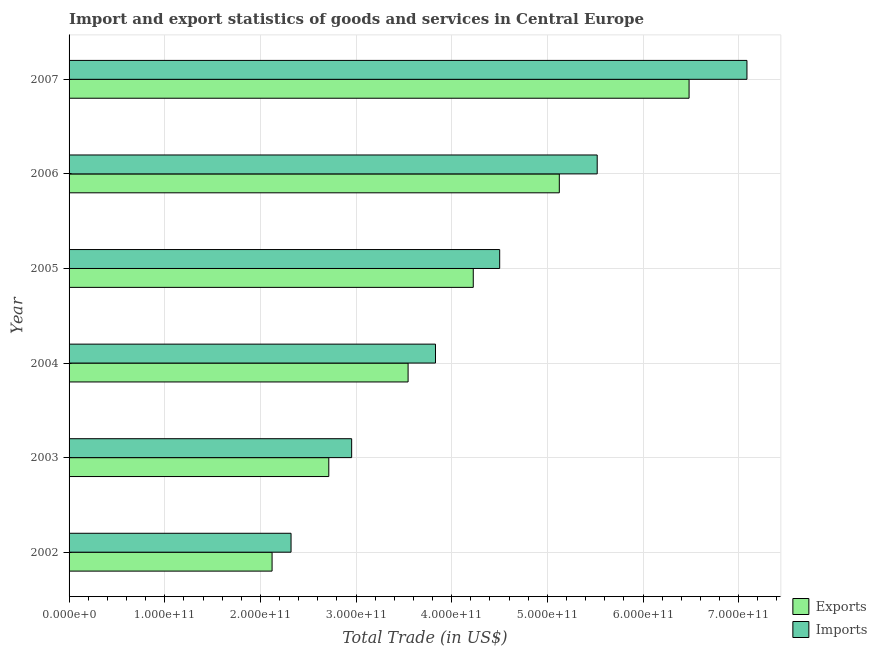How many different coloured bars are there?
Ensure brevity in your answer.  2. How many groups of bars are there?
Make the answer very short. 6. Are the number of bars per tick equal to the number of legend labels?
Your answer should be very brief. Yes. What is the export of goods and services in 2003?
Your answer should be very brief. 2.72e+11. Across all years, what is the maximum imports of goods and services?
Ensure brevity in your answer.  7.09e+11. Across all years, what is the minimum imports of goods and services?
Give a very brief answer. 2.32e+11. In which year was the imports of goods and services maximum?
Your response must be concise. 2007. In which year was the imports of goods and services minimum?
Offer a very short reply. 2002. What is the total imports of goods and services in the graph?
Your response must be concise. 2.62e+12. What is the difference between the imports of goods and services in 2003 and that in 2004?
Provide a succinct answer. -8.76e+1. What is the difference between the imports of goods and services in 2002 and the export of goods and services in 2007?
Offer a terse response. -4.16e+11. What is the average imports of goods and services per year?
Keep it short and to the point. 4.37e+11. In the year 2007, what is the difference between the export of goods and services and imports of goods and services?
Ensure brevity in your answer.  -6.05e+1. What is the ratio of the imports of goods and services in 2003 to that in 2006?
Give a very brief answer. 0.54. Is the imports of goods and services in 2003 less than that in 2007?
Your answer should be compact. Yes. What is the difference between the highest and the second highest export of goods and services?
Provide a succinct answer. 1.36e+11. What is the difference between the highest and the lowest export of goods and services?
Offer a very short reply. 4.36e+11. Is the sum of the imports of goods and services in 2002 and 2006 greater than the maximum export of goods and services across all years?
Your response must be concise. Yes. What does the 2nd bar from the top in 2004 represents?
Your response must be concise. Exports. What does the 1st bar from the bottom in 2003 represents?
Give a very brief answer. Exports. How many bars are there?
Make the answer very short. 12. Are all the bars in the graph horizontal?
Your answer should be compact. Yes. What is the difference between two consecutive major ticks on the X-axis?
Offer a terse response. 1.00e+11. Are the values on the major ticks of X-axis written in scientific E-notation?
Give a very brief answer. Yes. Where does the legend appear in the graph?
Keep it short and to the point. Bottom right. How many legend labels are there?
Ensure brevity in your answer.  2. What is the title of the graph?
Your answer should be very brief. Import and export statistics of goods and services in Central Europe. What is the label or title of the X-axis?
Make the answer very short. Total Trade (in US$). What is the label or title of the Y-axis?
Make the answer very short. Year. What is the Total Trade (in US$) of Exports in 2002?
Offer a terse response. 2.12e+11. What is the Total Trade (in US$) of Imports in 2002?
Provide a succinct answer. 2.32e+11. What is the Total Trade (in US$) of Exports in 2003?
Make the answer very short. 2.72e+11. What is the Total Trade (in US$) of Imports in 2003?
Ensure brevity in your answer.  2.95e+11. What is the Total Trade (in US$) in Exports in 2004?
Ensure brevity in your answer.  3.54e+11. What is the Total Trade (in US$) of Imports in 2004?
Give a very brief answer. 3.83e+11. What is the Total Trade (in US$) of Exports in 2005?
Give a very brief answer. 4.23e+11. What is the Total Trade (in US$) in Imports in 2005?
Provide a succinct answer. 4.50e+11. What is the Total Trade (in US$) in Exports in 2006?
Provide a short and direct response. 5.12e+11. What is the Total Trade (in US$) in Imports in 2006?
Give a very brief answer. 5.52e+11. What is the Total Trade (in US$) of Exports in 2007?
Offer a terse response. 6.48e+11. What is the Total Trade (in US$) of Imports in 2007?
Provide a succinct answer. 7.09e+11. Across all years, what is the maximum Total Trade (in US$) in Exports?
Make the answer very short. 6.48e+11. Across all years, what is the maximum Total Trade (in US$) in Imports?
Your response must be concise. 7.09e+11. Across all years, what is the minimum Total Trade (in US$) in Exports?
Make the answer very short. 2.12e+11. Across all years, what is the minimum Total Trade (in US$) of Imports?
Give a very brief answer. 2.32e+11. What is the total Total Trade (in US$) in Exports in the graph?
Provide a short and direct response. 2.42e+12. What is the total Total Trade (in US$) of Imports in the graph?
Ensure brevity in your answer.  2.62e+12. What is the difference between the Total Trade (in US$) in Exports in 2002 and that in 2003?
Make the answer very short. -5.93e+1. What is the difference between the Total Trade (in US$) of Imports in 2002 and that in 2003?
Your response must be concise. -6.34e+1. What is the difference between the Total Trade (in US$) in Exports in 2002 and that in 2004?
Ensure brevity in your answer.  -1.42e+11. What is the difference between the Total Trade (in US$) of Imports in 2002 and that in 2004?
Keep it short and to the point. -1.51e+11. What is the difference between the Total Trade (in US$) of Exports in 2002 and that in 2005?
Give a very brief answer. -2.10e+11. What is the difference between the Total Trade (in US$) of Imports in 2002 and that in 2005?
Your answer should be very brief. -2.18e+11. What is the difference between the Total Trade (in US$) in Exports in 2002 and that in 2006?
Your response must be concise. -3.00e+11. What is the difference between the Total Trade (in US$) in Imports in 2002 and that in 2006?
Your answer should be compact. -3.20e+11. What is the difference between the Total Trade (in US$) of Exports in 2002 and that in 2007?
Provide a short and direct response. -4.36e+11. What is the difference between the Total Trade (in US$) of Imports in 2002 and that in 2007?
Your answer should be compact. -4.77e+11. What is the difference between the Total Trade (in US$) of Exports in 2003 and that in 2004?
Your response must be concise. -8.29e+1. What is the difference between the Total Trade (in US$) in Imports in 2003 and that in 2004?
Offer a terse response. -8.76e+1. What is the difference between the Total Trade (in US$) of Exports in 2003 and that in 2005?
Your answer should be compact. -1.51e+11. What is the difference between the Total Trade (in US$) of Imports in 2003 and that in 2005?
Keep it short and to the point. -1.55e+11. What is the difference between the Total Trade (in US$) of Exports in 2003 and that in 2006?
Offer a very short reply. -2.41e+11. What is the difference between the Total Trade (in US$) of Imports in 2003 and that in 2006?
Your response must be concise. -2.57e+11. What is the difference between the Total Trade (in US$) in Exports in 2003 and that in 2007?
Provide a succinct answer. -3.77e+11. What is the difference between the Total Trade (in US$) of Imports in 2003 and that in 2007?
Offer a terse response. -4.13e+11. What is the difference between the Total Trade (in US$) in Exports in 2004 and that in 2005?
Provide a succinct answer. -6.81e+1. What is the difference between the Total Trade (in US$) of Imports in 2004 and that in 2005?
Give a very brief answer. -6.71e+1. What is the difference between the Total Trade (in US$) in Exports in 2004 and that in 2006?
Your response must be concise. -1.58e+11. What is the difference between the Total Trade (in US$) of Imports in 2004 and that in 2006?
Offer a terse response. -1.69e+11. What is the difference between the Total Trade (in US$) in Exports in 2004 and that in 2007?
Offer a very short reply. -2.94e+11. What is the difference between the Total Trade (in US$) of Imports in 2004 and that in 2007?
Your answer should be very brief. -3.26e+11. What is the difference between the Total Trade (in US$) in Exports in 2005 and that in 2006?
Provide a short and direct response. -8.99e+1. What is the difference between the Total Trade (in US$) in Imports in 2005 and that in 2006?
Provide a short and direct response. -1.02e+11. What is the difference between the Total Trade (in US$) of Exports in 2005 and that in 2007?
Offer a very short reply. -2.26e+11. What is the difference between the Total Trade (in US$) of Imports in 2005 and that in 2007?
Keep it short and to the point. -2.58e+11. What is the difference between the Total Trade (in US$) of Exports in 2006 and that in 2007?
Provide a succinct answer. -1.36e+11. What is the difference between the Total Trade (in US$) in Imports in 2006 and that in 2007?
Provide a succinct answer. -1.57e+11. What is the difference between the Total Trade (in US$) of Exports in 2002 and the Total Trade (in US$) of Imports in 2003?
Your answer should be very brief. -8.32e+1. What is the difference between the Total Trade (in US$) in Exports in 2002 and the Total Trade (in US$) in Imports in 2004?
Your answer should be compact. -1.71e+11. What is the difference between the Total Trade (in US$) in Exports in 2002 and the Total Trade (in US$) in Imports in 2005?
Ensure brevity in your answer.  -2.38e+11. What is the difference between the Total Trade (in US$) of Exports in 2002 and the Total Trade (in US$) of Imports in 2006?
Ensure brevity in your answer.  -3.40e+11. What is the difference between the Total Trade (in US$) of Exports in 2002 and the Total Trade (in US$) of Imports in 2007?
Give a very brief answer. -4.96e+11. What is the difference between the Total Trade (in US$) of Exports in 2003 and the Total Trade (in US$) of Imports in 2004?
Provide a succinct answer. -1.12e+11. What is the difference between the Total Trade (in US$) of Exports in 2003 and the Total Trade (in US$) of Imports in 2005?
Make the answer very short. -1.79e+11. What is the difference between the Total Trade (in US$) in Exports in 2003 and the Total Trade (in US$) in Imports in 2006?
Provide a succinct answer. -2.81e+11. What is the difference between the Total Trade (in US$) of Exports in 2003 and the Total Trade (in US$) of Imports in 2007?
Give a very brief answer. -4.37e+11. What is the difference between the Total Trade (in US$) of Exports in 2004 and the Total Trade (in US$) of Imports in 2005?
Your answer should be very brief. -9.57e+1. What is the difference between the Total Trade (in US$) of Exports in 2004 and the Total Trade (in US$) of Imports in 2006?
Ensure brevity in your answer.  -1.98e+11. What is the difference between the Total Trade (in US$) in Exports in 2004 and the Total Trade (in US$) in Imports in 2007?
Provide a succinct answer. -3.54e+11. What is the difference between the Total Trade (in US$) in Exports in 2005 and the Total Trade (in US$) in Imports in 2006?
Keep it short and to the point. -1.30e+11. What is the difference between the Total Trade (in US$) in Exports in 2005 and the Total Trade (in US$) in Imports in 2007?
Give a very brief answer. -2.86e+11. What is the difference between the Total Trade (in US$) in Exports in 2006 and the Total Trade (in US$) in Imports in 2007?
Your answer should be compact. -1.96e+11. What is the average Total Trade (in US$) of Exports per year?
Provide a short and direct response. 4.04e+11. What is the average Total Trade (in US$) of Imports per year?
Keep it short and to the point. 4.37e+11. In the year 2002, what is the difference between the Total Trade (in US$) in Exports and Total Trade (in US$) in Imports?
Give a very brief answer. -1.98e+1. In the year 2003, what is the difference between the Total Trade (in US$) in Exports and Total Trade (in US$) in Imports?
Provide a short and direct response. -2.39e+1. In the year 2004, what is the difference between the Total Trade (in US$) of Exports and Total Trade (in US$) of Imports?
Make the answer very short. -2.86e+1. In the year 2005, what is the difference between the Total Trade (in US$) in Exports and Total Trade (in US$) in Imports?
Your response must be concise. -2.76e+1. In the year 2006, what is the difference between the Total Trade (in US$) of Exports and Total Trade (in US$) of Imports?
Make the answer very short. -3.96e+1. In the year 2007, what is the difference between the Total Trade (in US$) of Exports and Total Trade (in US$) of Imports?
Offer a very short reply. -6.05e+1. What is the ratio of the Total Trade (in US$) in Exports in 2002 to that in 2003?
Give a very brief answer. 0.78. What is the ratio of the Total Trade (in US$) in Imports in 2002 to that in 2003?
Provide a succinct answer. 0.79. What is the ratio of the Total Trade (in US$) in Exports in 2002 to that in 2004?
Ensure brevity in your answer.  0.6. What is the ratio of the Total Trade (in US$) of Imports in 2002 to that in 2004?
Give a very brief answer. 0.61. What is the ratio of the Total Trade (in US$) in Exports in 2002 to that in 2005?
Provide a succinct answer. 0.5. What is the ratio of the Total Trade (in US$) of Imports in 2002 to that in 2005?
Your answer should be compact. 0.52. What is the ratio of the Total Trade (in US$) of Exports in 2002 to that in 2006?
Offer a terse response. 0.41. What is the ratio of the Total Trade (in US$) of Imports in 2002 to that in 2006?
Ensure brevity in your answer.  0.42. What is the ratio of the Total Trade (in US$) of Exports in 2002 to that in 2007?
Provide a short and direct response. 0.33. What is the ratio of the Total Trade (in US$) of Imports in 2002 to that in 2007?
Your response must be concise. 0.33. What is the ratio of the Total Trade (in US$) in Exports in 2003 to that in 2004?
Your response must be concise. 0.77. What is the ratio of the Total Trade (in US$) of Imports in 2003 to that in 2004?
Keep it short and to the point. 0.77. What is the ratio of the Total Trade (in US$) of Exports in 2003 to that in 2005?
Your response must be concise. 0.64. What is the ratio of the Total Trade (in US$) of Imports in 2003 to that in 2005?
Ensure brevity in your answer.  0.66. What is the ratio of the Total Trade (in US$) of Exports in 2003 to that in 2006?
Your answer should be very brief. 0.53. What is the ratio of the Total Trade (in US$) in Imports in 2003 to that in 2006?
Provide a succinct answer. 0.54. What is the ratio of the Total Trade (in US$) in Exports in 2003 to that in 2007?
Your answer should be very brief. 0.42. What is the ratio of the Total Trade (in US$) of Imports in 2003 to that in 2007?
Keep it short and to the point. 0.42. What is the ratio of the Total Trade (in US$) in Exports in 2004 to that in 2005?
Keep it short and to the point. 0.84. What is the ratio of the Total Trade (in US$) of Imports in 2004 to that in 2005?
Your response must be concise. 0.85. What is the ratio of the Total Trade (in US$) of Exports in 2004 to that in 2006?
Make the answer very short. 0.69. What is the ratio of the Total Trade (in US$) of Imports in 2004 to that in 2006?
Your answer should be compact. 0.69. What is the ratio of the Total Trade (in US$) in Exports in 2004 to that in 2007?
Offer a very short reply. 0.55. What is the ratio of the Total Trade (in US$) in Imports in 2004 to that in 2007?
Give a very brief answer. 0.54. What is the ratio of the Total Trade (in US$) of Exports in 2005 to that in 2006?
Make the answer very short. 0.82. What is the ratio of the Total Trade (in US$) in Imports in 2005 to that in 2006?
Give a very brief answer. 0.82. What is the ratio of the Total Trade (in US$) in Exports in 2005 to that in 2007?
Ensure brevity in your answer.  0.65. What is the ratio of the Total Trade (in US$) in Imports in 2005 to that in 2007?
Ensure brevity in your answer.  0.64. What is the ratio of the Total Trade (in US$) of Exports in 2006 to that in 2007?
Give a very brief answer. 0.79. What is the ratio of the Total Trade (in US$) of Imports in 2006 to that in 2007?
Provide a succinct answer. 0.78. What is the difference between the highest and the second highest Total Trade (in US$) of Exports?
Your response must be concise. 1.36e+11. What is the difference between the highest and the second highest Total Trade (in US$) of Imports?
Keep it short and to the point. 1.57e+11. What is the difference between the highest and the lowest Total Trade (in US$) of Exports?
Ensure brevity in your answer.  4.36e+11. What is the difference between the highest and the lowest Total Trade (in US$) of Imports?
Your response must be concise. 4.77e+11. 